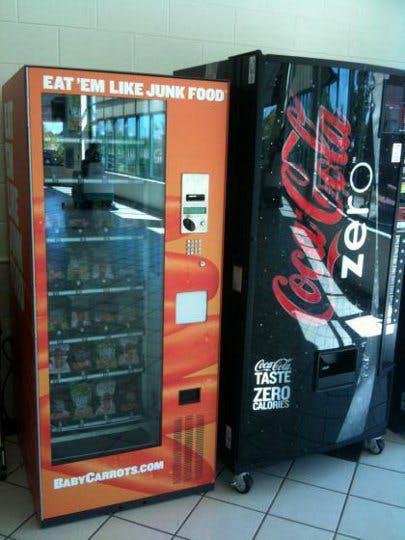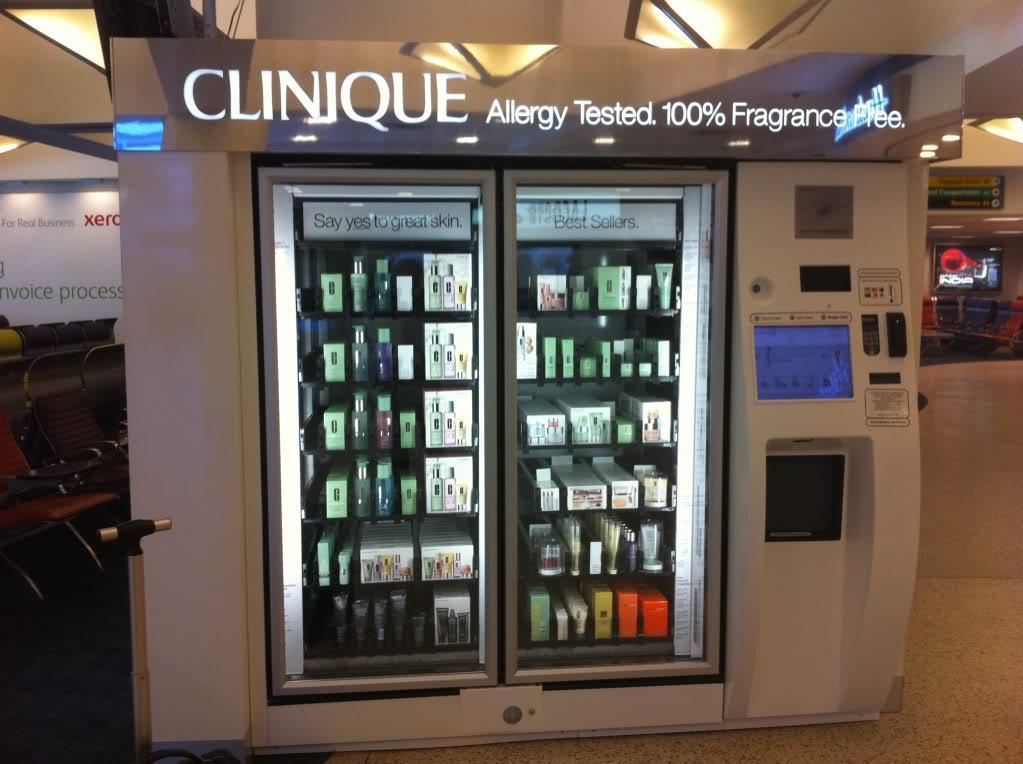The first image is the image on the left, the second image is the image on the right. Assess this claim about the two images: "At least one beverage vending machine has a blue 'wet look' front.". Correct or not? Answer yes or no. No. The first image is the image on the left, the second image is the image on the right. Examine the images to the left and right. Is the description "The left image contains at least one vending machine that is mostly blue in color." accurate? Answer yes or no. No. 